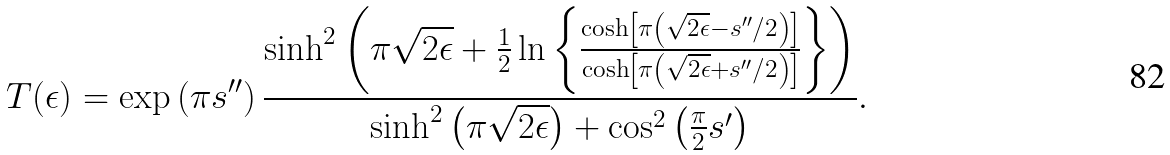<formula> <loc_0><loc_0><loc_500><loc_500>T ( \epsilon ) = \exp \left ( \pi s ^ { \prime \prime } \right ) \frac { \sinh ^ { 2 } \left ( \pi \sqrt { 2 \epsilon } + \frac { 1 } { 2 } \ln \left \{ \frac { \cosh \left [ \pi \left ( \sqrt { 2 \epsilon } - s ^ { \prime \prime } / 2 \right ) \right ] } { \cosh \left [ \pi \left ( \sqrt { 2 \epsilon } + s ^ { \prime \prime } / 2 \right ) \right ] } \right \} \right ) } { \sinh ^ { 2 } \left ( \pi \sqrt { 2 \epsilon } \right ) + \cos ^ { 2 } \left ( \frac { \pi } { 2 } s ^ { \prime } \right ) } .</formula> 